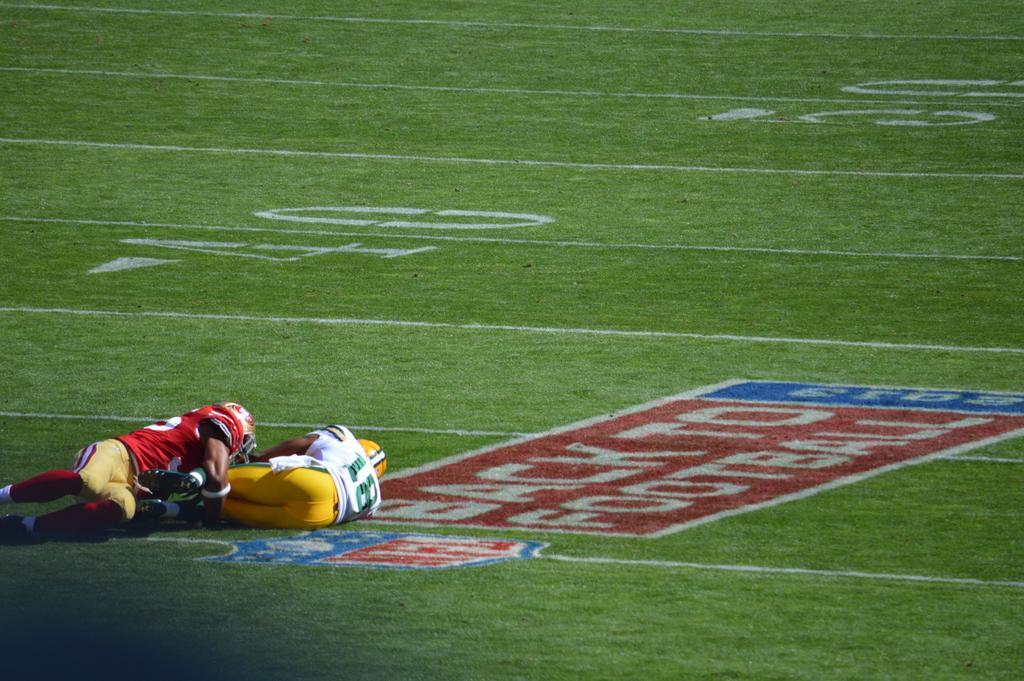Describe this image in one or two sentences. In this image in the center the persons are laying on the ground and there is grass on the ground. On the ground there is some text which is written in the center. 